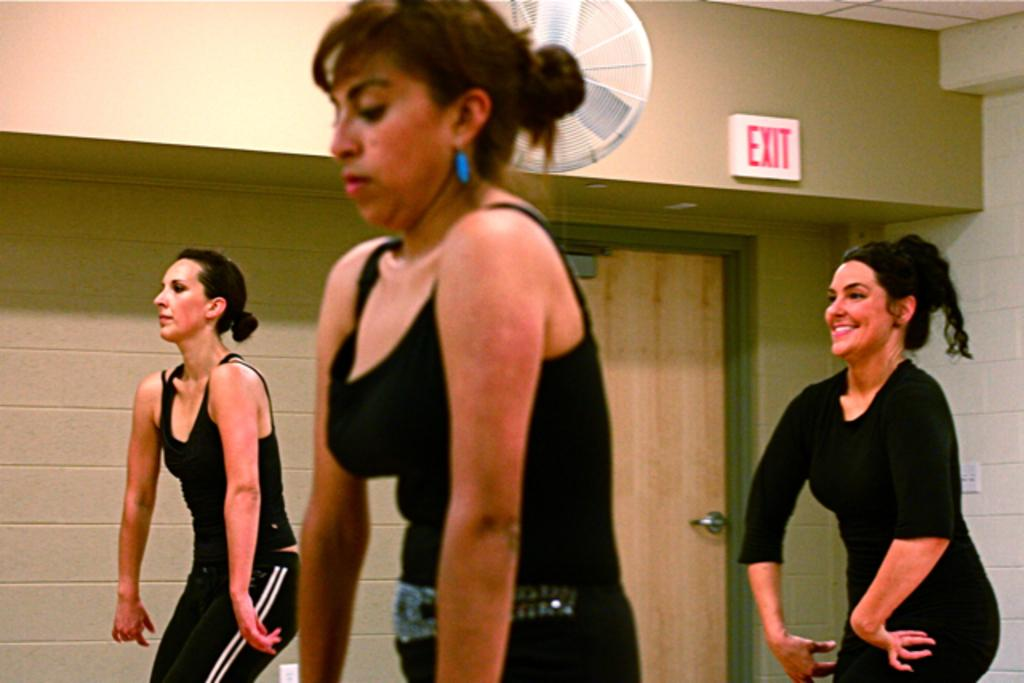What is the color of the wall in the image? The wall in the image is white. What electrical component can be seen in the image? There is a switch board in the image. What is a common feature of rooms that can be seen in the image? There is a door in the image. What is used for air circulation in the image? There is a fan in the image. How many women are present in the image? There are three women in the image. What color are the dresses worn by the women in the image? The women are wearing black color dresses. Can you see a trail of tin cans behind the women in the image? There is no trail of tin cans visible in the image. What is the cause of death for the person in the image? There is no person in the image, let alone any indication of death. 